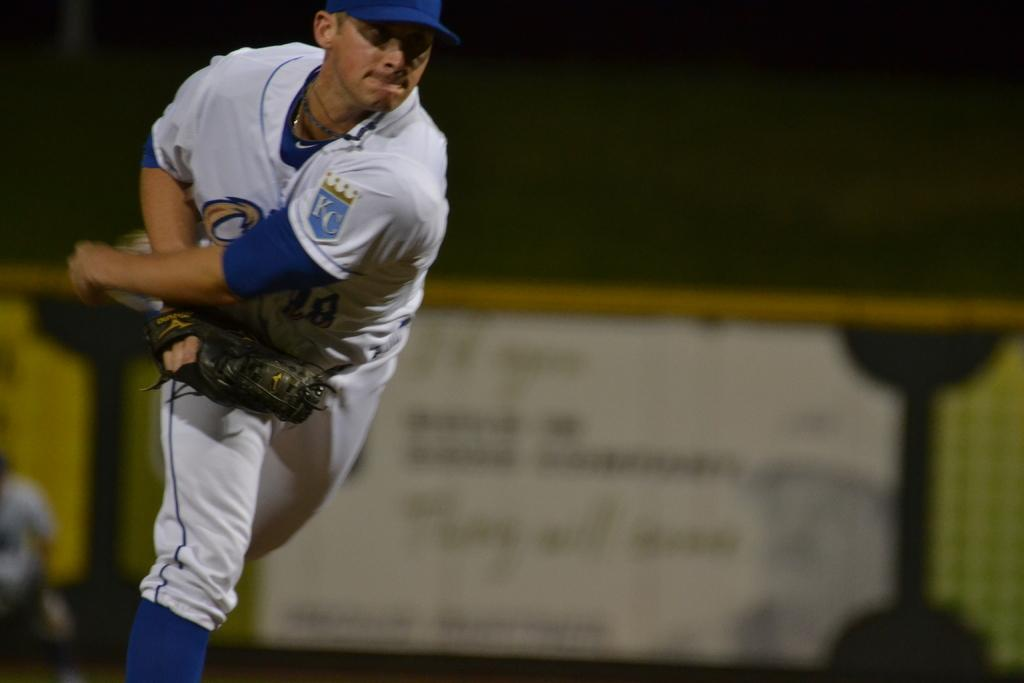<image>
Create a compact narrative representing the image presented. The letters KC are on the sleeve of the uniform of a baseball player. 